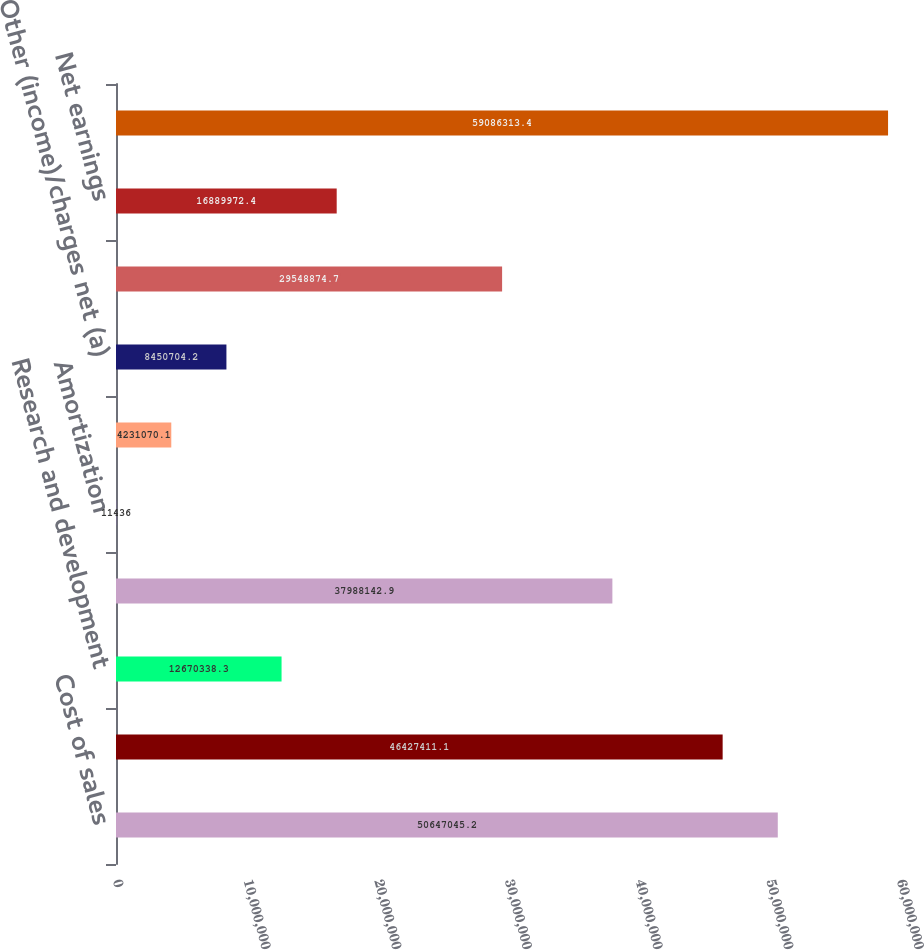<chart> <loc_0><loc_0><loc_500><loc_500><bar_chart><fcel>Cost of sales<fcel>Gross profit<fcel>Research and development<fcel>Selling general and<fcel>Amortization<fcel>Interest expense<fcel>Other (income)/charges net (a)<fcel>Earnings before taxes and<fcel>Net earnings<fcel>Weighted average number of<nl><fcel>5.0647e+07<fcel>4.64274e+07<fcel>1.26703e+07<fcel>3.79881e+07<fcel>11436<fcel>4.23107e+06<fcel>8.4507e+06<fcel>2.95489e+07<fcel>1.689e+07<fcel>5.90863e+07<nl></chart> 